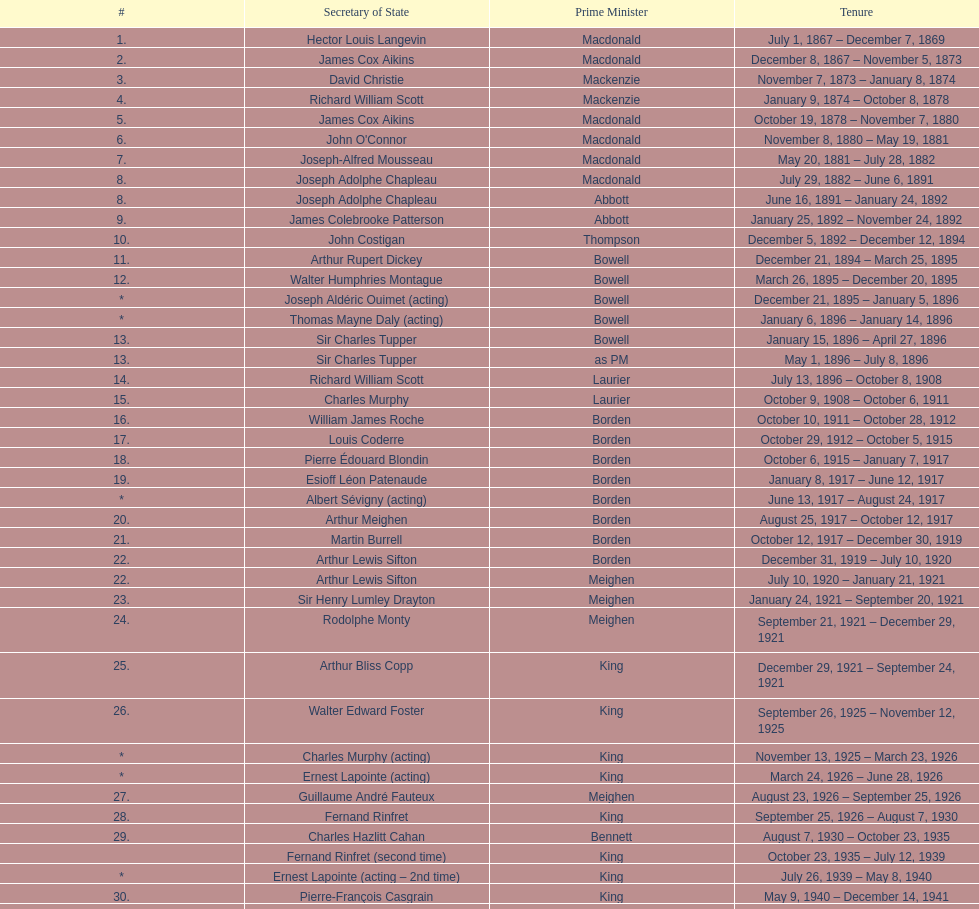During prime minister macdonald's time in office, how many individuals held the position of secretary of state? 6. 